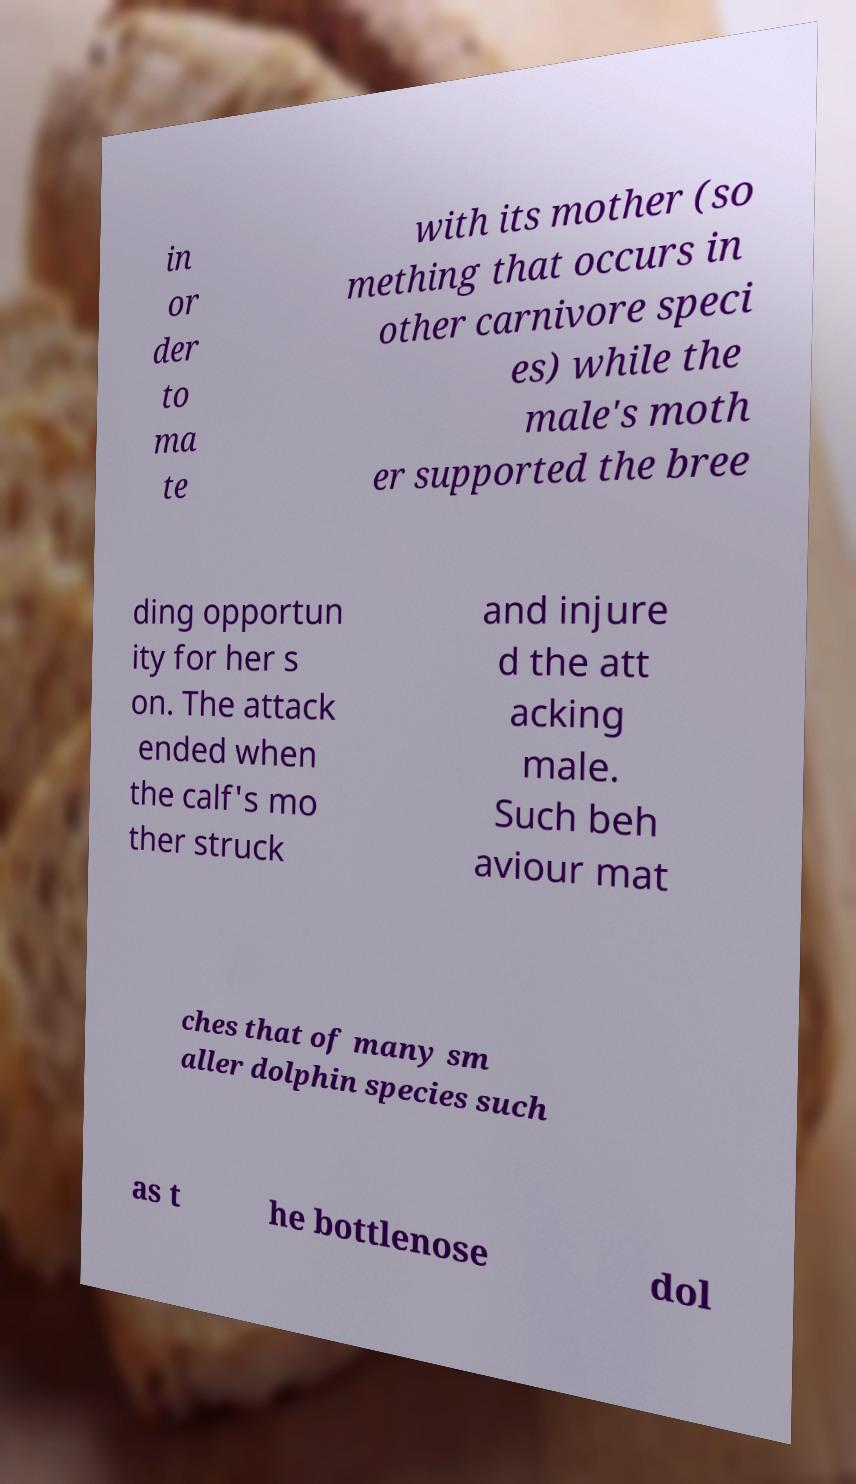Could you extract and type out the text from this image? in or der to ma te with its mother (so mething that occurs in other carnivore speci es) while the male's moth er supported the bree ding opportun ity for her s on. The attack ended when the calf's mo ther struck and injure d the att acking male. Such beh aviour mat ches that of many sm aller dolphin species such as t he bottlenose dol 